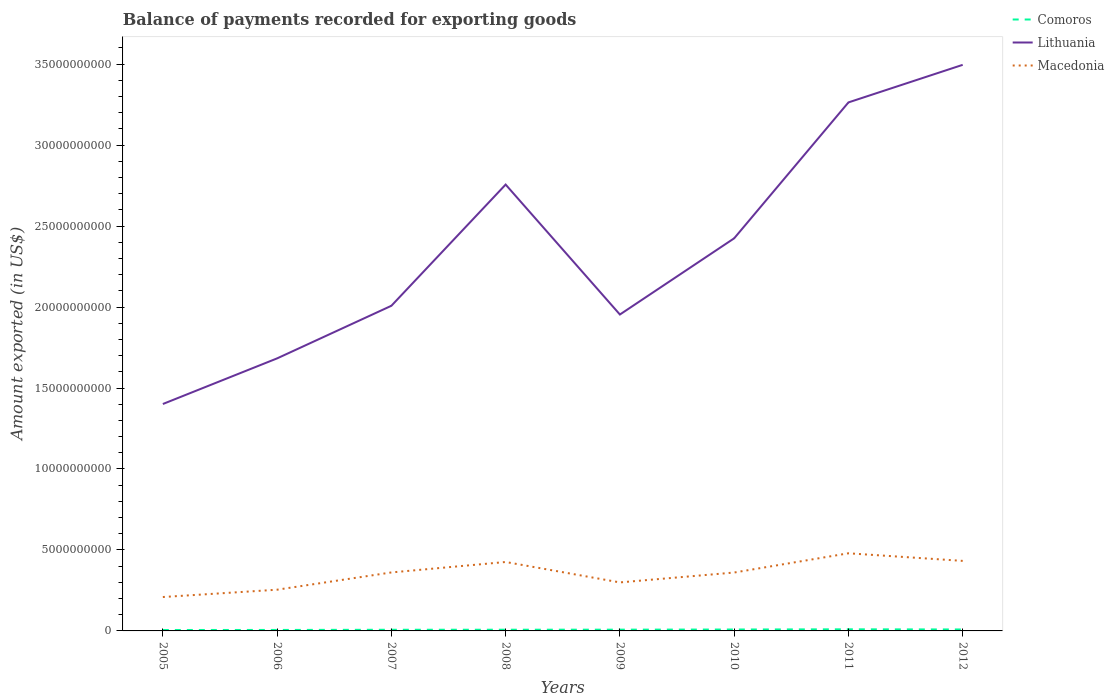Is the number of lines equal to the number of legend labels?
Offer a very short reply. Yes. Across all years, what is the maximum amount exported in Macedonia?
Offer a very short reply. 2.09e+09. In which year was the amount exported in Lithuania maximum?
Your answer should be compact. 2005. What is the total amount exported in Macedonia in the graph?
Keep it short and to the point. 4.69e+08. What is the difference between the highest and the second highest amount exported in Lithuania?
Offer a very short reply. 2.09e+1. What is the difference between the highest and the lowest amount exported in Comoros?
Keep it short and to the point. 4. How many years are there in the graph?
Ensure brevity in your answer.  8. What is the difference between two consecutive major ticks on the Y-axis?
Your answer should be very brief. 5.00e+09. Are the values on the major ticks of Y-axis written in scientific E-notation?
Offer a terse response. No. Does the graph contain any zero values?
Your response must be concise. No. Does the graph contain grids?
Keep it short and to the point. No. Where does the legend appear in the graph?
Your answer should be very brief. Top right. How are the legend labels stacked?
Your answer should be very brief. Vertical. What is the title of the graph?
Give a very brief answer. Balance of payments recorded for exporting goods. Does "Iran" appear as one of the legend labels in the graph?
Make the answer very short. No. What is the label or title of the Y-axis?
Give a very brief answer. Amount exported (in US$). What is the Amount exported (in US$) in Comoros in 2005?
Give a very brief answer. 5.71e+07. What is the Amount exported (in US$) in Lithuania in 2005?
Offer a very short reply. 1.40e+1. What is the Amount exported (in US$) of Macedonia in 2005?
Give a very brief answer. 2.09e+09. What is the Amount exported (in US$) in Comoros in 2006?
Give a very brief answer. 6.01e+07. What is the Amount exported (in US$) of Lithuania in 2006?
Give a very brief answer. 1.68e+1. What is the Amount exported (in US$) in Macedonia in 2006?
Give a very brief answer. 2.55e+09. What is the Amount exported (in US$) in Comoros in 2007?
Your answer should be very brief. 7.15e+07. What is the Amount exported (in US$) of Lithuania in 2007?
Offer a terse response. 2.01e+1. What is the Amount exported (in US$) in Macedonia in 2007?
Ensure brevity in your answer.  3.61e+09. What is the Amount exported (in US$) in Comoros in 2008?
Your response must be concise. 7.41e+07. What is the Amount exported (in US$) in Lithuania in 2008?
Provide a succinct answer. 2.76e+1. What is the Amount exported (in US$) of Macedonia in 2008?
Ensure brevity in your answer.  4.26e+09. What is the Amount exported (in US$) of Comoros in 2009?
Provide a succinct answer. 7.77e+07. What is the Amount exported (in US$) of Lithuania in 2009?
Your answer should be compact. 1.95e+1. What is the Amount exported (in US$) of Macedonia in 2009?
Offer a terse response. 3.00e+09. What is the Amount exported (in US$) in Comoros in 2010?
Provide a succinct answer. 8.74e+07. What is the Amount exported (in US$) in Lithuania in 2010?
Keep it short and to the point. 2.42e+1. What is the Amount exported (in US$) of Macedonia in 2010?
Your answer should be compact. 3.61e+09. What is the Amount exported (in US$) in Comoros in 2011?
Offer a very short reply. 9.96e+07. What is the Amount exported (in US$) of Lithuania in 2011?
Your response must be concise. 3.26e+1. What is the Amount exported (in US$) in Macedonia in 2011?
Offer a terse response. 4.79e+09. What is the Amount exported (in US$) of Comoros in 2012?
Your answer should be compact. 8.95e+07. What is the Amount exported (in US$) in Lithuania in 2012?
Your response must be concise. 3.50e+1. What is the Amount exported (in US$) of Macedonia in 2012?
Your answer should be very brief. 4.33e+09. Across all years, what is the maximum Amount exported (in US$) of Comoros?
Provide a succinct answer. 9.96e+07. Across all years, what is the maximum Amount exported (in US$) in Lithuania?
Your answer should be very brief. 3.50e+1. Across all years, what is the maximum Amount exported (in US$) in Macedonia?
Give a very brief answer. 4.79e+09. Across all years, what is the minimum Amount exported (in US$) in Comoros?
Your answer should be very brief. 5.71e+07. Across all years, what is the minimum Amount exported (in US$) in Lithuania?
Your response must be concise. 1.40e+1. Across all years, what is the minimum Amount exported (in US$) of Macedonia?
Offer a terse response. 2.09e+09. What is the total Amount exported (in US$) in Comoros in the graph?
Provide a succinct answer. 6.17e+08. What is the total Amount exported (in US$) in Lithuania in the graph?
Provide a short and direct response. 1.90e+11. What is the total Amount exported (in US$) in Macedonia in the graph?
Your answer should be compact. 2.82e+1. What is the difference between the Amount exported (in US$) of Comoros in 2005 and that in 2006?
Make the answer very short. -3.02e+06. What is the difference between the Amount exported (in US$) of Lithuania in 2005 and that in 2006?
Make the answer very short. -2.82e+09. What is the difference between the Amount exported (in US$) in Macedonia in 2005 and that in 2006?
Provide a short and direct response. -4.52e+08. What is the difference between the Amount exported (in US$) of Comoros in 2005 and that in 2007?
Provide a succinct answer. -1.44e+07. What is the difference between the Amount exported (in US$) of Lithuania in 2005 and that in 2007?
Provide a short and direct response. -6.07e+09. What is the difference between the Amount exported (in US$) in Macedonia in 2005 and that in 2007?
Offer a very short reply. -1.52e+09. What is the difference between the Amount exported (in US$) of Comoros in 2005 and that in 2008?
Offer a terse response. -1.70e+07. What is the difference between the Amount exported (in US$) in Lithuania in 2005 and that in 2008?
Provide a short and direct response. -1.36e+1. What is the difference between the Amount exported (in US$) of Macedonia in 2005 and that in 2008?
Give a very brief answer. -2.16e+09. What is the difference between the Amount exported (in US$) in Comoros in 2005 and that in 2009?
Ensure brevity in your answer.  -2.06e+07. What is the difference between the Amount exported (in US$) of Lithuania in 2005 and that in 2009?
Offer a terse response. -5.53e+09. What is the difference between the Amount exported (in US$) in Macedonia in 2005 and that in 2009?
Provide a succinct answer. -9.02e+08. What is the difference between the Amount exported (in US$) of Comoros in 2005 and that in 2010?
Provide a succinct answer. -3.03e+07. What is the difference between the Amount exported (in US$) in Lithuania in 2005 and that in 2010?
Keep it short and to the point. -1.02e+1. What is the difference between the Amount exported (in US$) of Macedonia in 2005 and that in 2010?
Your answer should be compact. -1.51e+09. What is the difference between the Amount exported (in US$) in Comoros in 2005 and that in 2011?
Offer a very short reply. -4.25e+07. What is the difference between the Amount exported (in US$) in Lithuania in 2005 and that in 2011?
Provide a short and direct response. -1.86e+1. What is the difference between the Amount exported (in US$) of Macedonia in 2005 and that in 2011?
Provide a succinct answer. -2.70e+09. What is the difference between the Amount exported (in US$) in Comoros in 2005 and that in 2012?
Give a very brief answer. -3.24e+07. What is the difference between the Amount exported (in US$) in Lithuania in 2005 and that in 2012?
Give a very brief answer. -2.09e+1. What is the difference between the Amount exported (in US$) in Macedonia in 2005 and that in 2012?
Give a very brief answer. -2.23e+09. What is the difference between the Amount exported (in US$) of Comoros in 2006 and that in 2007?
Keep it short and to the point. -1.14e+07. What is the difference between the Amount exported (in US$) of Lithuania in 2006 and that in 2007?
Make the answer very short. -3.25e+09. What is the difference between the Amount exported (in US$) in Macedonia in 2006 and that in 2007?
Your response must be concise. -1.07e+09. What is the difference between the Amount exported (in US$) of Comoros in 2006 and that in 2008?
Give a very brief answer. -1.40e+07. What is the difference between the Amount exported (in US$) of Lithuania in 2006 and that in 2008?
Your answer should be compact. -1.07e+1. What is the difference between the Amount exported (in US$) of Macedonia in 2006 and that in 2008?
Your response must be concise. -1.71e+09. What is the difference between the Amount exported (in US$) of Comoros in 2006 and that in 2009?
Make the answer very short. -1.76e+07. What is the difference between the Amount exported (in US$) in Lithuania in 2006 and that in 2009?
Your answer should be very brief. -2.71e+09. What is the difference between the Amount exported (in US$) in Macedonia in 2006 and that in 2009?
Ensure brevity in your answer.  -4.50e+08. What is the difference between the Amount exported (in US$) in Comoros in 2006 and that in 2010?
Keep it short and to the point. -2.73e+07. What is the difference between the Amount exported (in US$) of Lithuania in 2006 and that in 2010?
Keep it short and to the point. -7.41e+09. What is the difference between the Amount exported (in US$) of Macedonia in 2006 and that in 2010?
Your answer should be very brief. -1.06e+09. What is the difference between the Amount exported (in US$) in Comoros in 2006 and that in 2011?
Offer a very short reply. -3.95e+07. What is the difference between the Amount exported (in US$) in Lithuania in 2006 and that in 2011?
Keep it short and to the point. -1.58e+1. What is the difference between the Amount exported (in US$) in Macedonia in 2006 and that in 2011?
Offer a terse response. -2.25e+09. What is the difference between the Amount exported (in US$) of Comoros in 2006 and that in 2012?
Your response must be concise. -2.94e+07. What is the difference between the Amount exported (in US$) of Lithuania in 2006 and that in 2012?
Your response must be concise. -1.81e+1. What is the difference between the Amount exported (in US$) in Macedonia in 2006 and that in 2012?
Your response must be concise. -1.78e+09. What is the difference between the Amount exported (in US$) of Comoros in 2007 and that in 2008?
Make the answer very short. -2.64e+06. What is the difference between the Amount exported (in US$) of Lithuania in 2007 and that in 2008?
Your answer should be compact. -7.49e+09. What is the difference between the Amount exported (in US$) of Macedonia in 2007 and that in 2008?
Offer a very short reply. -6.45e+08. What is the difference between the Amount exported (in US$) of Comoros in 2007 and that in 2009?
Your answer should be compact. -6.22e+06. What is the difference between the Amount exported (in US$) of Lithuania in 2007 and that in 2009?
Keep it short and to the point. 5.40e+08. What is the difference between the Amount exported (in US$) in Macedonia in 2007 and that in 2009?
Your response must be concise. 6.16e+08. What is the difference between the Amount exported (in US$) of Comoros in 2007 and that in 2010?
Give a very brief answer. -1.59e+07. What is the difference between the Amount exported (in US$) in Lithuania in 2007 and that in 2010?
Make the answer very short. -4.17e+09. What is the difference between the Amount exported (in US$) in Macedonia in 2007 and that in 2010?
Give a very brief answer. 5.36e+06. What is the difference between the Amount exported (in US$) of Comoros in 2007 and that in 2011?
Offer a very short reply. -2.82e+07. What is the difference between the Amount exported (in US$) in Lithuania in 2007 and that in 2011?
Your answer should be compact. -1.26e+1. What is the difference between the Amount exported (in US$) of Macedonia in 2007 and that in 2011?
Provide a succinct answer. -1.18e+09. What is the difference between the Amount exported (in US$) in Comoros in 2007 and that in 2012?
Provide a succinct answer. -1.81e+07. What is the difference between the Amount exported (in US$) of Lithuania in 2007 and that in 2012?
Give a very brief answer. -1.49e+1. What is the difference between the Amount exported (in US$) of Macedonia in 2007 and that in 2012?
Your answer should be compact. -7.13e+08. What is the difference between the Amount exported (in US$) of Comoros in 2008 and that in 2009?
Your answer should be compact. -3.57e+06. What is the difference between the Amount exported (in US$) of Lithuania in 2008 and that in 2009?
Make the answer very short. 8.03e+09. What is the difference between the Amount exported (in US$) of Macedonia in 2008 and that in 2009?
Your response must be concise. 1.26e+09. What is the difference between the Amount exported (in US$) in Comoros in 2008 and that in 2010?
Give a very brief answer. -1.33e+07. What is the difference between the Amount exported (in US$) of Lithuania in 2008 and that in 2010?
Your answer should be very brief. 3.32e+09. What is the difference between the Amount exported (in US$) of Macedonia in 2008 and that in 2010?
Give a very brief answer. 6.51e+08. What is the difference between the Amount exported (in US$) of Comoros in 2008 and that in 2011?
Provide a short and direct response. -2.55e+07. What is the difference between the Amount exported (in US$) of Lithuania in 2008 and that in 2011?
Your answer should be very brief. -5.07e+09. What is the difference between the Amount exported (in US$) of Macedonia in 2008 and that in 2011?
Offer a very short reply. -5.37e+08. What is the difference between the Amount exported (in US$) of Comoros in 2008 and that in 2012?
Give a very brief answer. -1.54e+07. What is the difference between the Amount exported (in US$) of Lithuania in 2008 and that in 2012?
Ensure brevity in your answer.  -7.39e+09. What is the difference between the Amount exported (in US$) in Macedonia in 2008 and that in 2012?
Provide a succinct answer. -6.80e+07. What is the difference between the Amount exported (in US$) in Comoros in 2009 and that in 2010?
Keep it short and to the point. -9.73e+06. What is the difference between the Amount exported (in US$) of Lithuania in 2009 and that in 2010?
Keep it short and to the point. -4.71e+09. What is the difference between the Amount exported (in US$) of Macedonia in 2009 and that in 2010?
Give a very brief answer. -6.11e+08. What is the difference between the Amount exported (in US$) of Comoros in 2009 and that in 2011?
Offer a terse response. -2.19e+07. What is the difference between the Amount exported (in US$) of Lithuania in 2009 and that in 2011?
Your response must be concise. -1.31e+1. What is the difference between the Amount exported (in US$) in Macedonia in 2009 and that in 2011?
Your answer should be compact. -1.80e+09. What is the difference between the Amount exported (in US$) of Comoros in 2009 and that in 2012?
Give a very brief answer. -1.18e+07. What is the difference between the Amount exported (in US$) in Lithuania in 2009 and that in 2012?
Provide a short and direct response. -1.54e+1. What is the difference between the Amount exported (in US$) in Macedonia in 2009 and that in 2012?
Your answer should be very brief. -1.33e+09. What is the difference between the Amount exported (in US$) in Comoros in 2010 and that in 2011?
Offer a very short reply. -1.22e+07. What is the difference between the Amount exported (in US$) of Lithuania in 2010 and that in 2011?
Give a very brief answer. -8.39e+09. What is the difference between the Amount exported (in US$) of Macedonia in 2010 and that in 2011?
Keep it short and to the point. -1.19e+09. What is the difference between the Amount exported (in US$) in Comoros in 2010 and that in 2012?
Give a very brief answer. -2.11e+06. What is the difference between the Amount exported (in US$) of Lithuania in 2010 and that in 2012?
Your answer should be compact. -1.07e+1. What is the difference between the Amount exported (in US$) of Macedonia in 2010 and that in 2012?
Offer a very short reply. -7.19e+08. What is the difference between the Amount exported (in US$) of Comoros in 2011 and that in 2012?
Give a very brief answer. 1.01e+07. What is the difference between the Amount exported (in US$) in Lithuania in 2011 and that in 2012?
Your answer should be very brief. -2.32e+09. What is the difference between the Amount exported (in US$) of Macedonia in 2011 and that in 2012?
Your answer should be compact. 4.69e+08. What is the difference between the Amount exported (in US$) in Comoros in 2005 and the Amount exported (in US$) in Lithuania in 2006?
Keep it short and to the point. -1.68e+1. What is the difference between the Amount exported (in US$) of Comoros in 2005 and the Amount exported (in US$) of Macedonia in 2006?
Make the answer very short. -2.49e+09. What is the difference between the Amount exported (in US$) of Lithuania in 2005 and the Amount exported (in US$) of Macedonia in 2006?
Provide a succinct answer. 1.15e+1. What is the difference between the Amount exported (in US$) of Comoros in 2005 and the Amount exported (in US$) of Lithuania in 2007?
Your answer should be very brief. -2.00e+1. What is the difference between the Amount exported (in US$) of Comoros in 2005 and the Amount exported (in US$) of Macedonia in 2007?
Ensure brevity in your answer.  -3.55e+09. What is the difference between the Amount exported (in US$) of Lithuania in 2005 and the Amount exported (in US$) of Macedonia in 2007?
Give a very brief answer. 1.04e+1. What is the difference between the Amount exported (in US$) of Comoros in 2005 and the Amount exported (in US$) of Lithuania in 2008?
Make the answer very short. -2.75e+1. What is the difference between the Amount exported (in US$) of Comoros in 2005 and the Amount exported (in US$) of Macedonia in 2008?
Your response must be concise. -4.20e+09. What is the difference between the Amount exported (in US$) in Lithuania in 2005 and the Amount exported (in US$) in Macedonia in 2008?
Your response must be concise. 9.76e+09. What is the difference between the Amount exported (in US$) in Comoros in 2005 and the Amount exported (in US$) in Lithuania in 2009?
Your answer should be compact. -1.95e+1. What is the difference between the Amount exported (in US$) in Comoros in 2005 and the Amount exported (in US$) in Macedonia in 2009?
Keep it short and to the point. -2.94e+09. What is the difference between the Amount exported (in US$) in Lithuania in 2005 and the Amount exported (in US$) in Macedonia in 2009?
Provide a succinct answer. 1.10e+1. What is the difference between the Amount exported (in US$) in Comoros in 2005 and the Amount exported (in US$) in Lithuania in 2010?
Offer a very short reply. -2.42e+1. What is the difference between the Amount exported (in US$) of Comoros in 2005 and the Amount exported (in US$) of Macedonia in 2010?
Provide a short and direct response. -3.55e+09. What is the difference between the Amount exported (in US$) in Lithuania in 2005 and the Amount exported (in US$) in Macedonia in 2010?
Your answer should be compact. 1.04e+1. What is the difference between the Amount exported (in US$) of Comoros in 2005 and the Amount exported (in US$) of Lithuania in 2011?
Provide a short and direct response. -3.26e+1. What is the difference between the Amount exported (in US$) of Comoros in 2005 and the Amount exported (in US$) of Macedonia in 2011?
Give a very brief answer. -4.74e+09. What is the difference between the Amount exported (in US$) in Lithuania in 2005 and the Amount exported (in US$) in Macedonia in 2011?
Ensure brevity in your answer.  9.22e+09. What is the difference between the Amount exported (in US$) in Comoros in 2005 and the Amount exported (in US$) in Lithuania in 2012?
Your answer should be compact. -3.49e+1. What is the difference between the Amount exported (in US$) of Comoros in 2005 and the Amount exported (in US$) of Macedonia in 2012?
Provide a short and direct response. -4.27e+09. What is the difference between the Amount exported (in US$) in Lithuania in 2005 and the Amount exported (in US$) in Macedonia in 2012?
Ensure brevity in your answer.  9.69e+09. What is the difference between the Amount exported (in US$) of Comoros in 2006 and the Amount exported (in US$) of Lithuania in 2007?
Make the answer very short. -2.00e+1. What is the difference between the Amount exported (in US$) in Comoros in 2006 and the Amount exported (in US$) in Macedonia in 2007?
Your answer should be very brief. -3.55e+09. What is the difference between the Amount exported (in US$) of Lithuania in 2006 and the Amount exported (in US$) of Macedonia in 2007?
Your response must be concise. 1.32e+1. What is the difference between the Amount exported (in US$) in Comoros in 2006 and the Amount exported (in US$) in Lithuania in 2008?
Make the answer very short. -2.75e+1. What is the difference between the Amount exported (in US$) of Comoros in 2006 and the Amount exported (in US$) of Macedonia in 2008?
Provide a short and direct response. -4.20e+09. What is the difference between the Amount exported (in US$) in Lithuania in 2006 and the Amount exported (in US$) in Macedonia in 2008?
Ensure brevity in your answer.  1.26e+1. What is the difference between the Amount exported (in US$) of Comoros in 2006 and the Amount exported (in US$) of Lithuania in 2009?
Ensure brevity in your answer.  -1.95e+1. What is the difference between the Amount exported (in US$) in Comoros in 2006 and the Amount exported (in US$) in Macedonia in 2009?
Offer a very short reply. -2.94e+09. What is the difference between the Amount exported (in US$) of Lithuania in 2006 and the Amount exported (in US$) of Macedonia in 2009?
Give a very brief answer. 1.38e+1. What is the difference between the Amount exported (in US$) in Comoros in 2006 and the Amount exported (in US$) in Lithuania in 2010?
Offer a very short reply. -2.42e+1. What is the difference between the Amount exported (in US$) of Comoros in 2006 and the Amount exported (in US$) of Macedonia in 2010?
Your answer should be very brief. -3.55e+09. What is the difference between the Amount exported (in US$) of Lithuania in 2006 and the Amount exported (in US$) of Macedonia in 2010?
Provide a succinct answer. 1.32e+1. What is the difference between the Amount exported (in US$) in Comoros in 2006 and the Amount exported (in US$) in Lithuania in 2011?
Your response must be concise. -3.26e+1. What is the difference between the Amount exported (in US$) of Comoros in 2006 and the Amount exported (in US$) of Macedonia in 2011?
Give a very brief answer. -4.73e+09. What is the difference between the Amount exported (in US$) in Lithuania in 2006 and the Amount exported (in US$) in Macedonia in 2011?
Ensure brevity in your answer.  1.20e+1. What is the difference between the Amount exported (in US$) of Comoros in 2006 and the Amount exported (in US$) of Lithuania in 2012?
Ensure brevity in your answer.  -3.49e+1. What is the difference between the Amount exported (in US$) in Comoros in 2006 and the Amount exported (in US$) in Macedonia in 2012?
Ensure brevity in your answer.  -4.26e+09. What is the difference between the Amount exported (in US$) of Lithuania in 2006 and the Amount exported (in US$) of Macedonia in 2012?
Make the answer very short. 1.25e+1. What is the difference between the Amount exported (in US$) of Comoros in 2007 and the Amount exported (in US$) of Lithuania in 2008?
Offer a terse response. -2.75e+1. What is the difference between the Amount exported (in US$) in Comoros in 2007 and the Amount exported (in US$) in Macedonia in 2008?
Your response must be concise. -4.19e+09. What is the difference between the Amount exported (in US$) of Lithuania in 2007 and the Amount exported (in US$) of Macedonia in 2008?
Your answer should be compact. 1.58e+1. What is the difference between the Amount exported (in US$) of Comoros in 2007 and the Amount exported (in US$) of Lithuania in 2009?
Make the answer very short. -1.95e+1. What is the difference between the Amount exported (in US$) of Comoros in 2007 and the Amount exported (in US$) of Macedonia in 2009?
Offer a terse response. -2.92e+09. What is the difference between the Amount exported (in US$) of Lithuania in 2007 and the Amount exported (in US$) of Macedonia in 2009?
Provide a succinct answer. 1.71e+1. What is the difference between the Amount exported (in US$) of Comoros in 2007 and the Amount exported (in US$) of Lithuania in 2010?
Provide a succinct answer. -2.42e+1. What is the difference between the Amount exported (in US$) in Comoros in 2007 and the Amount exported (in US$) in Macedonia in 2010?
Your answer should be very brief. -3.53e+09. What is the difference between the Amount exported (in US$) in Lithuania in 2007 and the Amount exported (in US$) in Macedonia in 2010?
Offer a terse response. 1.65e+1. What is the difference between the Amount exported (in US$) of Comoros in 2007 and the Amount exported (in US$) of Lithuania in 2011?
Offer a very short reply. -3.26e+1. What is the difference between the Amount exported (in US$) in Comoros in 2007 and the Amount exported (in US$) in Macedonia in 2011?
Give a very brief answer. -4.72e+09. What is the difference between the Amount exported (in US$) of Lithuania in 2007 and the Amount exported (in US$) of Macedonia in 2011?
Your answer should be very brief. 1.53e+1. What is the difference between the Amount exported (in US$) of Comoros in 2007 and the Amount exported (in US$) of Lithuania in 2012?
Your answer should be compact. -3.49e+1. What is the difference between the Amount exported (in US$) of Comoros in 2007 and the Amount exported (in US$) of Macedonia in 2012?
Provide a short and direct response. -4.25e+09. What is the difference between the Amount exported (in US$) of Lithuania in 2007 and the Amount exported (in US$) of Macedonia in 2012?
Make the answer very short. 1.58e+1. What is the difference between the Amount exported (in US$) of Comoros in 2008 and the Amount exported (in US$) of Lithuania in 2009?
Ensure brevity in your answer.  -1.95e+1. What is the difference between the Amount exported (in US$) of Comoros in 2008 and the Amount exported (in US$) of Macedonia in 2009?
Keep it short and to the point. -2.92e+09. What is the difference between the Amount exported (in US$) of Lithuania in 2008 and the Amount exported (in US$) of Macedonia in 2009?
Keep it short and to the point. 2.46e+1. What is the difference between the Amount exported (in US$) of Comoros in 2008 and the Amount exported (in US$) of Lithuania in 2010?
Offer a terse response. -2.42e+1. What is the difference between the Amount exported (in US$) of Comoros in 2008 and the Amount exported (in US$) of Macedonia in 2010?
Offer a terse response. -3.53e+09. What is the difference between the Amount exported (in US$) in Lithuania in 2008 and the Amount exported (in US$) in Macedonia in 2010?
Provide a short and direct response. 2.40e+1. What is the difference between the Amount exported (in US$) in Comoros in 2008 and the Amount exported (in US$) in Lithuania in 2011?
Offer a terse response. -3.26e+1. What is the difference between the Amount exported (in US$) in Comoros in 2008 and the Amount exported (in US$) in Macedonia in 2011?
Provide a short and direct response. -4.72e+09. What is the difference between the Amount exported (in US$) of Lithuania in 2008 and the Amount exported (in US$) of Macedonia in 2011?
Ensure brevity in your answer.  2.28e+1. What is the difference between the Amount exported (in US$) in Comoros in 2008 and the Amount exported (in US$) in Lithuania in 2012?
Your answer should be very brief. -3.49e+1. What is the difference between the Amount exported (in US$) of Comoros in 2008 and the Amount exported (in US$) of Macedonia in 2012?
Your response must be concise. -4.25e+09. What is the difference between the Amount exported (in US$) of Lithuania in 2008 and the Amount exported (in US$) of Macedonia in 2012?
Your answer should be very brief. 2.32e+1. What is the difference between the Amount exported (in US$) in Comoros in 2009 and the Amount exported (in US$) in Lithuania in 2010?
Offer a very short reply. -2.42e+1. What is the difference between the Amount exported (in US$) of Comoros in 2009 and the Amount exported (in US$) of Macedonia in 2010?
Provide a short and direct response. -3.53e+09. What is the difference between the Amount exported (in US$) of Lithuania in 2009 and the Amount exported (in US$) of Macedonia in 2010?
Provide a short and direct response. 1.59e+1. What is the difference between the Amount exported (in US$) in Comoros in 2009 and the Amount exported (in US$) in Lithuania in 2011?
Your answer should be compact. -3.26e+1. What is the difference between the Amount exported (in US$) of Comoros in 2009 and the Amount exported (in US$) of Macedonia in 2011?
Provide a short and direct response. -4.72e+09. What is the difference between the Amount exported (in US$) in Lithuania in 2009 and the Amount exported (in US$) in Macedonia in 2011?
Provide a succinct answer. 1.47e+1. What is the difference between the Amount exported (in US$) in Comoros in 2009 and the Amount exported (in US$) in Lithuania in 2012?
Keep it short and to the point. -3.49e+1. What is the difference between the Amount exported (in US$) of Comoros in 2009 and the Amount exported (in US$) of Macedonia in 2012?
Provide a succinct answer. -4.25e+09. What is the difference between the Amount exported (in US$) in Lithuania in 2009 and the Amount exported (in US$) in Macedonia in 2012?
Provide a short and direct response. 1.52e+1. What is the difference between the Amount exported (in US$) of Comoros in 2010 and the Amount exported (in US$) of Lithuania in 2011?
Your answer should be compact. -3.26e+1. What is the difference between the Amount exported (in US$) of Comoros in 2010 and the Amount exported (in US$) of Macedonia in 2011?
Provide a succinct answer. -4.71e+09. What is the difference between the Amount exported (in US$) in Lithuania in 2010 and the Amount exported (in US$) in Macedonia in 2011?
Keep it short and to the point. 1.95e+1. What is the difference between the Amount exported (in US$) of Comoros in 2010 and the Amount exported (in US$) of Lithuania in 2012?
Ensure brevity in your answer.  -3.49e+1. What is the difference between the Amount exported (in US$) of Comoros in 2010 and the Amount exported (in US$) of Macedonia in 2012?
Provide a succinct answer. -4.24e+09. What is the difference between the Amount exported (in US$) in Lithuania in 2010 and the Amount exported (in US$) in Macedonia in 2012?
Provide a succinct answer. 1.99e+1. What is the difference between the Amount exported (in US$) in Comoros in 2011 and the Amount exported (in US$) in Lithuania in 2012?
Give a very brief answer. -3.49e+1. What is the difference between the Amount exported (in US$) in Comoros in 2011 and the Amount exported (in US$) in Macedonia in 2012?
Offer a terse response. -4.23e+09. What is the difference between the Amount exported (in US$) in Lithuania in 2011 and the Amount exported (in US$) in Macedonia in 2012?
Give a very brief answer. 2.83e+1. What is the average Amount exported (in US$) of Comoros per year?
Ensure brevity in your answer.  7.71e+07. What is the average Amount exported (in US$) of Lithuania per year?
Keep it short and to the point. 2.37e+1. What is the average Amount exported (in US$) of Macedonia per year?
Your answer should be very brief. 3.53e+09. In the year 2005, what is the difference between the Amount exported (in US$) in Comoros and Amount exported (in US$) in Lithuania?
Keep it short and to the point. -1.40e+1. In the year 2005, what is the difference between the Amount exported (in US$) of Comoros and Amount exported (in US$) of Macedonia?
Your response must be concise. -2.04e+09. In the year 2005, what is the difference between the Amount exported (in US$) in Lithuania and Amount exported (in US$) in Macedonia?
Provide a succinct answer. 1.19e+1. In the year 2006, what is the difference between the Amount exported (in US$) in Comoros and Amount exported (in US$) in Lithuania?
Keep it short and to the point. -1.68e+1. In the year 2006, what is the difference between the Amount exported (in US$) of Comoros and Amount exported (in US$) of Macedonia?
Make the answer very short. -2.49e+09. In the year 2006, what is the difference between the Amount exported (in US$) in Lithuania and Amount exported (in US$) in Macedonia?
Offer a very short reply. 1.43e+1. In the year 2007, what is the difference between the Amount exported (in US$) of Comoros and Amount exported (in US$) of Lithuania?
Provide a short and direct response. -2.00e+1. In the year 2007, what is the difference between the Amount exported (in US$) of Comoros and Amount exported (in US$) of Macedonia?
Keep it short and to the point. -3.54e+09. In the year 2007, what is the difference between the Amount exported (in US$) of Lithuania and Amount exported (in US$) of Macedonia?
Your answer should be very brief. 1.65e+1. In the year 2008, what is the difference between the Amount exported (in US$) in Comoros and Amount exported (in US$) in Lithuania?
Your answer should be compact. -2.75e+1. In the year 2008, what is the difference between the Amount exported (in US$) of Comoros and Amount exported (in US$) of Macedonia?
Provide a succinct answer. -4.18e+09. In the year 2008, what is the difference between the Amount exported (in US$) of Lithuania and Amount exported (in US$) of Macedonia?
Ensure brevity in your answer.  2.33e+1. In the year 2009, what is the difference between the Amount exported (in US$) of Comoros and Amount exported (in US$) of Lithuania?
Provide a succinct answer. -1.95e+1. In the year 2009, what is the difference between the Amount exported (in US$) in Comoros and Amount exported (in US$) in Macedonia?
Give a very brief answer. -2.92e+09. In the year 2009, what is the difference between the Amount exported (in US$) of Lithuania and Amount exported (in US$) of Macedonia?
Your response must be concise. 1.65e+1. In the year 2010, what is the difference between the Amount exported (in US$) of Comoros and Amount exported (in US$) of Lithuania?
Provide a succinct answer. -2.42e+1. In the year 2010, what is the difference between the Amount exported (in US$) of Comoros and Amount exported (in US$) of Macedonia?
Your answer should be very brief. -3.52e+09. In the year 2010, what is the difference between the Amount exported (in US$) in Lithuania and Amount exported (in US$) in Macedonia?
Offer a very short reply. 2.06e+1. In the year 2011, what is the difference between the Amount exported (in US$) of Comoros and Amount exported (in US$) of Lithuania?
Offer a very short reply. -3.25e+1. In the year 2011, what is the difference between the Amount exported (in US$) in Comoros and Amount exported (in US$) in Macedonia?
Ensure brevity in your answer.  -4.69e+09. In the year 2011, what is the difference between the Amount exported (in US$) of Lithuania and Amount exported (in US$) of Macedonia?
Your response must be concise. 2.78e+1. In the year 2012, what is the difference between the Amount exported (in US$) of Comoros and Amount exported (in US$) of Lithuania?
Ensure brevity in your answer.  -3.49e+1. In the year 2012, what is the difference between the Amount exported (in US$) of Comoros and Amount exported (in US$) of Macedonia?
Your answer should be compact. -4.24e+09. In the year 2012, what is the difference between the Amount exported (in US$) of Lithuania and Amount exported (in US$) of Macedonia?
Your answer should be compact. 3.06e+1. What is the ratio of the Amount exported (in US$) in Comoros in 2005 to that in 2006?
Keep it short and to the point. 0.95. What is the ratio of the Amount exported (in US$) in Lithuania in 2005 to that in 2006?
Your answer should be very brief. 0.83. What is the ratio of the Amount exported (in US$) in Macedonia in 2005 to that in 2006?
Give a very brief answer. 0.82. What is the ratio of the Amount exported (in US$) of Comoros in 2005 to that in 2007?
Give a very brief answer. 0.8. What is the ratio of the Amount exported (in US$) of Lithuania in 2005 to that in 2007?
Keep it short and to the point. 0.7. What is the ratio of the Amount exported (in US$) of Macedonia in 2005 to that in 2007?
Provide a succinct answer. 0.58. What is the ratio of the Amount exported (in US$) of Comoros in 2005 to that in 2008?
Ensure brevity in your answer.  0.77. What is the ratio of the Amount exported (in US$) in Lithuania in 2005 to that in 2008?
Keep it short and to the point. 0.51. What is the ratio of the Amount exported (in US$) of Macedonia in 2005 to that in 2008?
Your answer should be compact. 0.49. What is the ratio of the Amount exported (in US$) in Comoros in 2005 to that in 2009?
Provide a short and direct response. 0.73. What is the ratio of the Amount exported (in US$) of Lithuania in 2005 to that in 2009?
Give a very brief answer. 0.72. What is the ratio of the Amount exported (in US$) of Macedonia in 2005 to that in 2009?
Provide a succinct answer. 0.7. What is the ratio of the Amount exported (in US$) in Comoros in 2005 to that in 2010?
Your answer should be very brief. 0.65. What is the ratio of the Amount exported (in US$) of Lithuania in 2005 to that in 2010?
Offer a very short reply. 0.58. What is the ratio of the Amount exported (in US$) of Macedonia in 2005 to that in 2010?
Provide a short and direct response. 0.58. What is the ratio of the Amount exported (in US$) in Comoros in 2005 to that in 2011?
Your response must be concise. 0.57. What is the ratio of the Amount exported (in US$) of Lithuania in 2005 to that in 2011?
Provide a succinct answer. 0.43. What is the ratio of the Amount exported (in US$) of Macedonia in 2005 to that in 2011?
Offer a terse response. 0.44. What is the ratio of the Amount exported (in US$) of Comoros in 2005 to that in 2012?
Make the answer very short. 0.64. What is the ratio of the Amount exported (in US$) of Lithuania in 2005 to that in 2012?
Provide a succinct answer. 0.4. What is the ratio of the Amount exported (in US$) of Macedonia in 2005 to that in 2012?
Keep it short and to the point. 0.48. What is the ratio of the Amount exported (in US$) of Comoros in 2006 to that in 2007?
Offer a terse response. 0.84. What is the ratio of the Amount exported (in US$) of Lithuania in 2006 to that in 2007?
Provide a succinct answer. 0.84. What is the ratio of the Amount exported (in US$) in Macedonia in 2006 to that in 2007?
Your response must be concise. 0.7. What is the ratio of the Amount exported (in US$) in Comoros in 2006 to that in 2008?
Your response must be concise. 0.81. What is the ratio of the Amount exported (in US$) in Lithuania in 2006 to that in 2008?
Your answer should be compact. 0.61. What is the ratio of the Amount exported (in US$) in Macedonia in 2006 to that in 2008?
Your answer should be very brief. 0.6. What is the ratio of the Amount exported (in US$) in Comoros in 2006 to that in 2009?
Your answer should be very brief. 0.77. What is the ratio of the Amount exported (in US$) of Lithuania in 2006 to that in 2009?
Offer a terse response. 0.86. What is the ratio of the Amount exported (in US$) of Macedonia in 2006 to that in 2009?
Keep it short and to the point. 0.85. What is the ratio of the Amount exported (in US$) of Comoros in 2006 to that in 2010?
Make the answer very short. 0.69. What is the ratio of the Amount exported (in US$) in Lithuania in 2006 to that in 2010?
Your answer should be compact. 0.69. What is the ratio of the Amount exported (in US$) of Macedonia in 2006 to that in 2010?
Your answer should be very brief. 0.71. What is the ratio of the Amount exported (in US$) in Comoros in 2006 to that in 2011?
Offer a terse response. 0.6. What is the ratio of the Amount exported (in US$) of Lithuania in 2006 to that in 2011?
Your response must be concise. 0.52. What is the ratio of the Amount exported (in US$) of Macedonia in 2006 to that in 2011?
Your response must be concise. 0.53. What is the ratio of the Amount exported (in US$) in Comoros in 2006 to that in 2012?
Your response must be concise. 0.67. What is the ratio of the Amount exported (in US$) in Lithuania in 2006 to that in 2012?
Offer a very short reply. 0.48. What is the ratio of the Amount exported (in US$) in Macedonia in 2006 to that in 2012?
Offer a terse response. 0.59. What is the ratio of the Amount exported (in US$) of Comoros in 2007 to that in 2008?
Your response must be concise. 0.96. What is the ratio of the Amount exported (in US$) of Lithuania in 2007 to that in 2008?
Keep it short and to the point. 0.73. What is the ratio of the Amount exported (in US$) of Macedonia in 2007 to that in 2008?
Give a very brief answer. 0.85. What is the ratio of the Amount exported (in US$) of Lithuania in 2007 to that in 2009?
Keep it short and to the point. 1.03. What is the ratio of the Amount exported (in US$) of Macedonia in 2007 to that in 2009?
Offer a very short reply. 1.21. What is the ratio of the Amount exported (in US$) of Comoros in 2007 to that in 2010?
Your answer should be very brief. 0.82. What is the ratio of the Amount exported (in US$) in Lithuania in 2007 to that in 2010?
Give a very brief answer. 0.83. What is the ratio of the Amount exported (in US$) in Comoros in 2007 to that in 2011?
Keep it short and to the point. 0.72. What is the ratio of the Amount exported (in US$) of Lithuania in 2007 to that in 2011?
Your response must be concise. 0.62. What is the ratio of the Amount exported (in US$) of Macedonia in 2007 to that in 2011?
Make the answer very short. 0.75. What is the ratio of the Amount exported (in US$) in Comoros in 2007 to that in 2012?
Provide a succinct answer. 0.8. What is the ratio of the Amount exported (in US$) of Lithuania in 2007 to that in 2012?
Keep it short and to the point. 0.57. What is the ratio of the Amount exported (in US$) of Macedonia in 2007 to that in 2012?
Your answer should be very brief. 0.84. What is the ratio of the Amount exported (in US$) in Comoros in 2008 to that in 2009?
Keep it short and to the point. 0.95. What is the ratio of the Amount exported (in US$) in Lithuania in 2008 to that in 2009?
Provide a succinct answer. 1.41. What is the ratio of the Amount exported (in US$) in Macedonia in 2008 to that in 2009?
Your answer should be very brief. 1.42. What is the ratio of the Amount exported (in US$) in Comoros in 2008 to that in 2010?
Your response must be concise. 0.85. What is the ratio of the Amount exported (in US$) of Lithuania in 2008 to that in 2010?
Your answer should be compact. 1.14. What is the ratio of the Amount exported (in US$) of Macedonia in 2008 to that in 2010?
Ensure brevity in your answer.  1.18. What is the ratio of the Amount exported (in US$) of Comoros in 2008 to that in 2011?
Your answer should be very brief. 0.74. What is the ratio of the Amount exported (in US$) in Lithuania in 2008 to that in 2011?
Your answer should be compact. 0.84. What is the ratio of the Amount exported (in US$) of Macedonia in 2008 to that in 2011?
Make the answer very short. 0.89. What is the ratio of the Amount exported (in US$) of Comoros in 2008 to that in 2012?
Provide a succinct answer. 0.83. What is the ratio of the Amount exported (in US$) in Lithuania in 2008 to that in 2012?
Make the answer very short. 0.79. What is the ratio of the Amount exported (in US$) in Macedonia in 2008 to that in 2012?
Offer a terse response. 0.98. What is the ratio of the Amount exported (in US$) of Comoros in 2009 to that in 2010?
Provide a succinct answer. 0.89. What is the ratio of the Amount exported (in US$) of Lithuania in 2009 to that in 2010?
Your response must be concise. 0.81. What is the ratio of the Amount exported (in US$) in Macedonia in 2009 to that in 2010?
Your answer should be compact. 0.83. What is the ratio of the Amount exported (in US$) in Comoros in 2009 to that in 2011?
Offer a terse response. 0.78. What is the ratio of the Amount exported (in US$) of Lithuania in 2009 to that in 2011?
Provide a short and direct response. 0.6. What is the ratio of the Amount exported (in US$) of Macedonia in 2009 to that in 2011?
Make the answer very short. 0.62. What is the ratio of the Amount exported (in US$) in Comoros in 2009 to that in 2012?
Ensure brevity in your answer.  0.87. What is the ratio of the Amount exported (in US$) of Lithuania in 2009 to that in 2012?
Offer a very short reply. 0.56. What is the ratio of the Amount exported (in US$) in Macedonia in 2009 to that in 2012?
Your response must be concise. 0.69. What is the ratio of the Amount exported (in US$) of Comoros in 2010 to that in 2011?
Keep it short and to the point. 0.88. What is the ratio of the Amount exported (in US$) of Lithuania in 2010 to that in 2011?
Keep it short and to the point. 0.74. What is the ratio of the Amount exported (in US$) of Macedonia in 2010 to that in 2011?
Offer a very short reply. 0.75. What is the ratio of the Amount exported (in US$) of Comoros in 2010 to that in 2012?
Offer a terse response. 0.98. What is the ratio of the Amount exported (in US$) of Lithuania in 2010 to that in 2012?
Keep it short and to the point. 0.69. What is the ratio of the Amount exported (in US$) of Macedonia in 2010 to that in 2012?
Your answer should be very brief. 0.83. What is the ratio of the Amount exported (in US$) of Comoros in 2011 to that in 2012?
Make the answer very short. 1.11. What is the ratio of the Amount exported (in US$) of Lithuania in 2011 to that in 2012?
Keep it short and to the point. 0.93. What is the ratio of the Amount exported (in US$) in Macedonia in 2011 to that in 2012?
Your answer should be compact. 1.11. What is the difference between the highest and the second highest Amount exported (in US$) of Comoros?
Give a very brief answer. 1.01e+07. What is the difference between the highest and the second highest Amount exported (in US$) of Lithuania?
Provide a short and direct response. 2.32e+09. What is the difference between the highest and the second highest Amount exported (in US$) in Macedonia?
Give a very brief answer. 4.69e+08. What is the difference between the highest and the lowest Amount exported (in US$) of Comoros?
Offer a terse response. 4.25e+07. What is the difference between the highest and the lowest Amount exported (in US$) of Lithuania?
Offer a terse response. 2.09e+1. What is the difference between the highest and the lowest Amount exported (in US$) of Macedonia?
Offer a very short reply. 2.70e+09. 